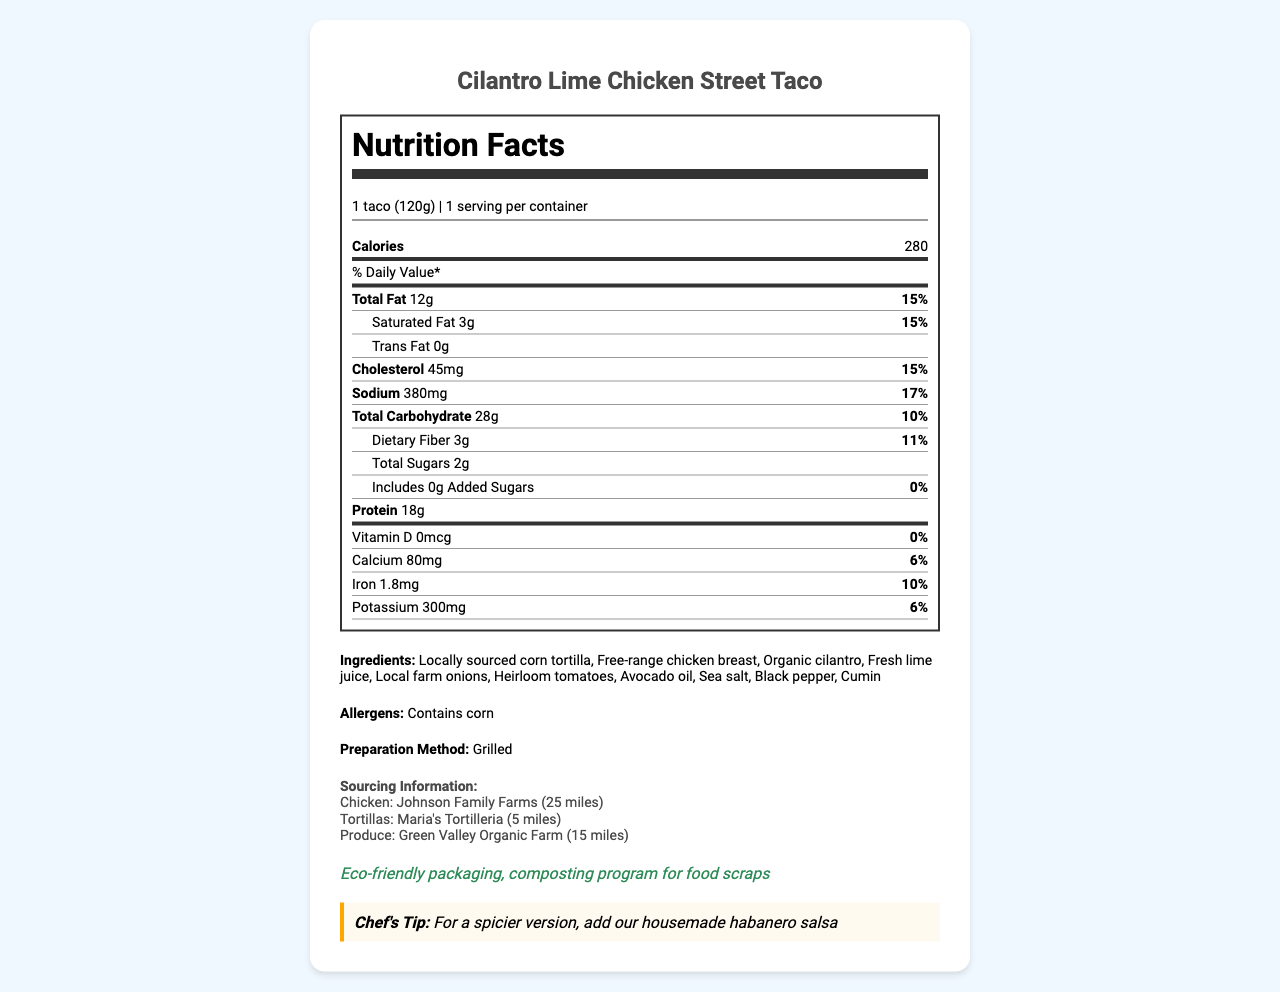How many calories are in one Cilantro Lime Chicken Street Taco? The document states that one serving of the street taco contains 280 calories.
Answer: 280 What is the main preparation method for the taco? The "preparation method" section of the document indicates that the tacos are grilled.
Answer: Grilled What percentage of the daily value of sodium does the taco contain? In the "Sodium" row, it is stated that the taco contains 380 mg of sodium, which is 17% of the daily value.
Answer: 17% What is the protein content per serving? The "Protein" row indicates that the taco has 18 grams of protein per serving.
Answer: 18g What are the main allergens in the taco? The allergens section lists corn as a potential allergen.
Answer: Corn Multiple-choice: Which of the following ingredients is not included in the taco? A) Heirloom tomatoes B) Free-range chicken breast C) Mozzarella cheese The ingredients list does not mention mozzarella cheese, but it does include heirloom tomatoes and free-range chicken breast.
Answer: C Multiple-choice: What is the daily value percentage of saturated fat in the taco? A) 10% B) 15% C) 20% According to the document, the daily value percentage of saturated fat is 15%.
Answer: B Yes/No: Does the taco contain any added sugars? The document specifies that the taco contains 0 grams of added sugars.
Answer: No Summary: Describe the main information provided in the document. The document is comprehensive and includes both nutritional facts and additional information relevant to consumers, such as allergen content and sourcing details.
Answer: The document provides detailed nutritional information about the Cilantro Lime Chicken Street Taco, including serving size, calorie count, and daily values for various nutrients. It also lists the ingredients, preparation method, sourcing information, sustainability notes, and a chef's tip. How many grams of dietary fiber are in the taco? The "Dietary Fiber" row indicates that there are 3 grams of dietary fiber per serving.
Answer: 3g What is the main source of the chicken used in the tacos? The sourcing information section states that the chicken is sourced from Johnson Family Farms.
Answer: Johnson Family Farms (25 miles) Unanswerable: How long should the taco be cooked for optimal flavor? The document provides preparation methods but does not specify cooking times.
Answer: Not enough information What is the suggested way to make the taco spicier? The chef's tips section suggests adding housemade habanero salsa for a spicier version of the taco.
Answer: Add housemade habanero salsa What is the ecological aspect noted in the document? The sustainability notes highlight eco-friendly packaging and a composting program for food scraps.
Answer: Eco-friendly packaging, composting program for food scraps 